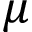Convert formula to latex. <formula><loc_0><loc_0><loc_500><loc_500>\mu</formula> 